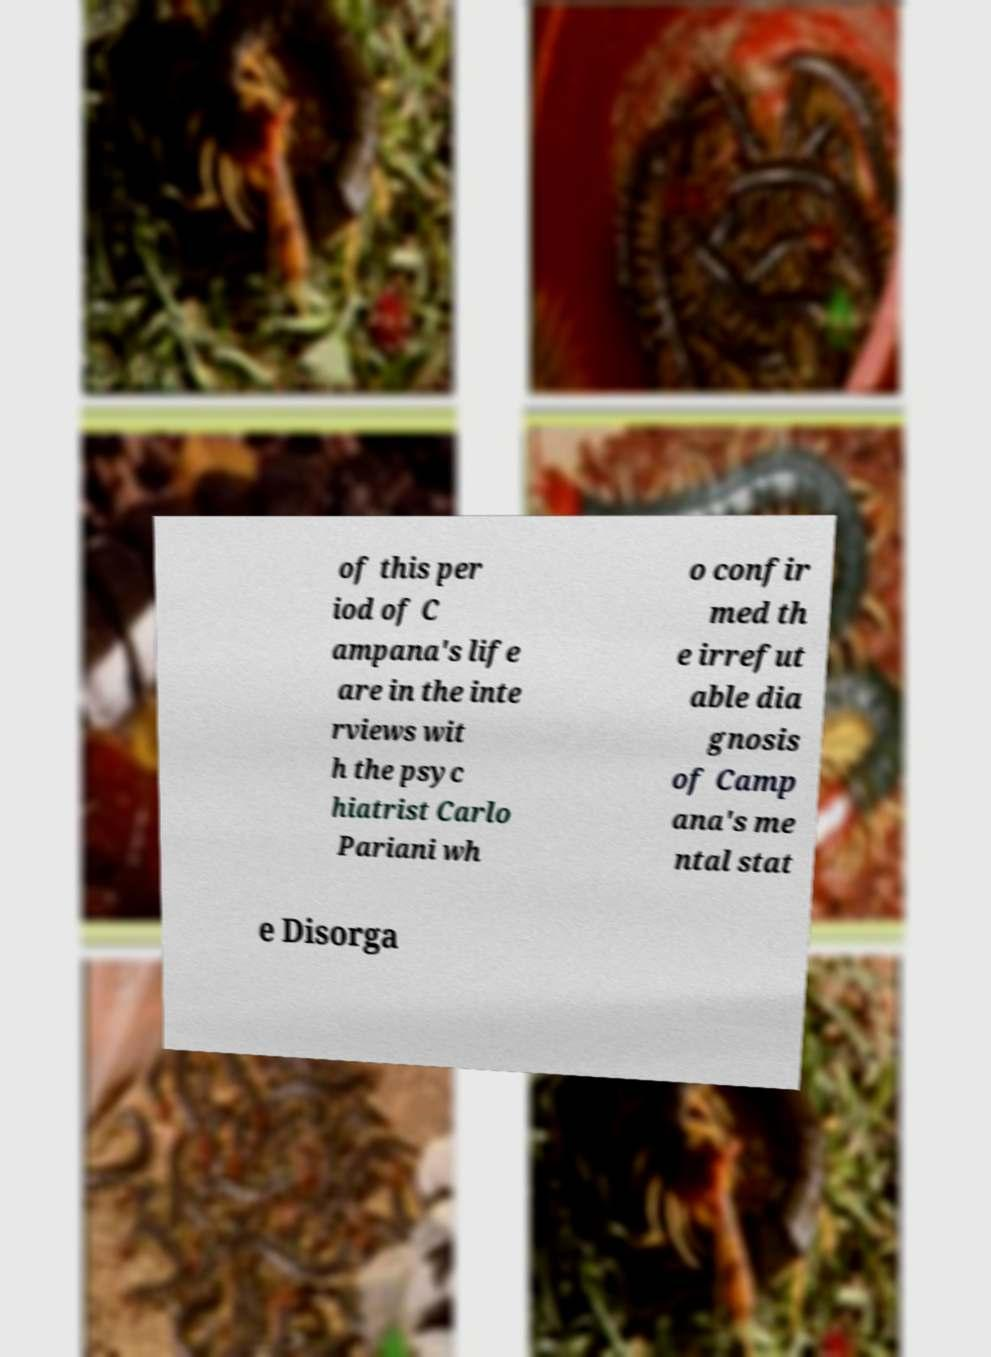Please identify and transcribe the text found in this image. of this per iod of C ampana's life are in the inte rviews wit h the psyc hiatrist Carlo Pariani wh o confir med th e irrefut able dia gnosis of Camp ana's me ntal stat e Disorga 